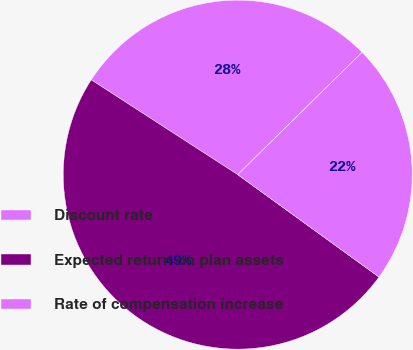<chart> <loc_0><loc_0><loc_500><loc_500><pie_chart><fcel>Discount rate<fcel>Expected return on plan assets<fcel>Rate of compensation increase<nl><fcel>28.49%<fcel>49.16%<fcel>22.35%<nl></chart> 